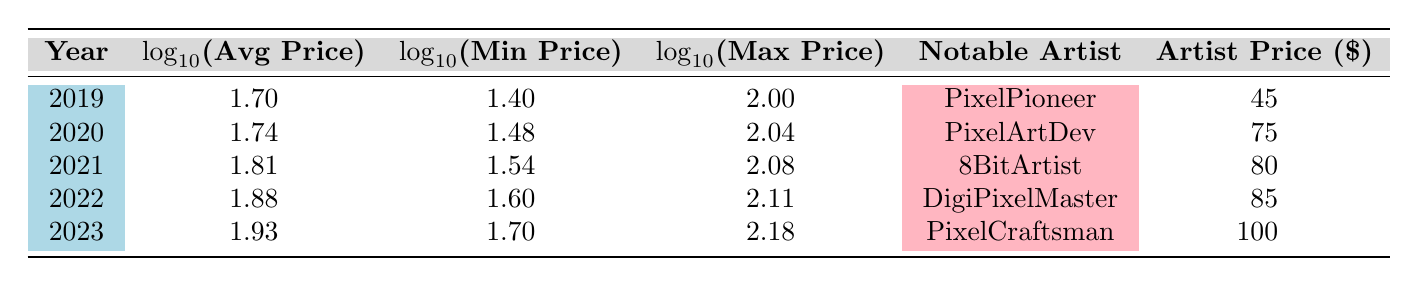What was the average price of pixel art commissions in 2021? From the table, the average price for 2021 is directly listed under the "Average Price" column. It shows that the average price was 65 USD.
Answer: 65 USD What is the minimum price listed in 2022? The minimum price for 2022 can be found under the "Min Price" column for the year 2022, which is marked as 40 USD.
Answer: 40 USD Which artist had the highest price per piece in 2020? Looking through the artists listed for 2020, PixelArtDev has the highest price per piece at 75 USD.
Answer: PixelArtDev Is the average price of pixel art commissions increasing each year? By looking at the average prices from 2019 to 2023, the average prices are 50, 55, 65, 75, and 85 USD, respectively. Since these values are all increasing, the answer is yes.
Answer: Yes What is the difference in average price from 2019 to 2023? To calculate the difference: take the average price in 2023 (85 USD) and subtract the average price in 2019 (50 USD). The difference is 85 - 50 = 35 USD.
Answer: 35 USD What are the logarithmic values for the maximum price in 2021? The logarithmic value for the maximum price in 2021 can be found in the "Log Max Price" column for the year 2021. It is given as approximately 2.08.
Answer: 2.08 Did any artist's price exceed the maximum price in 2022? The maximum price in 2022 is 130 USD. Looking at the artists' prices, DigiPixelMaster's price is 85 USD and PixelPalette's is 70 USD, both below 130 USD. Therefore, no artist's price exceeded the maximum price.
Answer: No What was the highest logarithmic value of the average price between 2019 and 2023? Reviewing the "Log Avg Price" column from 2019 to 2023, the value for 2023 is 1.93, which is higher than the values for earlier years (1.70, 1.74, 1.81, 1.88). Therefore, the highest logarithmic value is for 2023.
Answer: 1.93 What is the range of average prices captured in the table from 2019 to 2023? The average prices for the years range from 50 USD in 2019 to 85 USD in 2023. To find the range, compute 85 - 50 = 35 USD.
Answer: 35 USD 